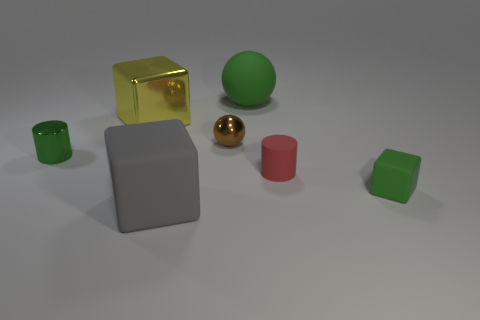Does the big cube that is to the right of the big yellow metal cube have the same material as the large object that is right of the large rubber cube?
Your answer should be compact. Yes. There is a tiny matte cylinder; are there any big metal things left of it?
Your answer should be very brief. Yes. What number of green objects are metal blocks or spheres?
Your answer should be very brief. 1. Is the material of the green cube the same as the cylinder that is to the right of the tiny shiny ball?
Make the answer very short. Yes. What is the size of the gray rubber object that is the same shape as the large metal object?
Your response must be concise. Large. What is the material of the tiny green cube?
Your answer should be very brief. Rubber. What is the material of the cylinder right of the large object that is in front of the small matte object that is to the right of the red rubber cylinder?
Offer a very short reply. Rubber. Do the green object on the left side of the large gray block and the green rubber thing that is in front of the brown ball have the same size?
Make the answer very short. Yes. How many other objects are there of the same material as the brown thing?
Make the answer very short. 2. How many rubber things are red cylinders or big gray cubes?
Ensure brevity in your answer.  2. 